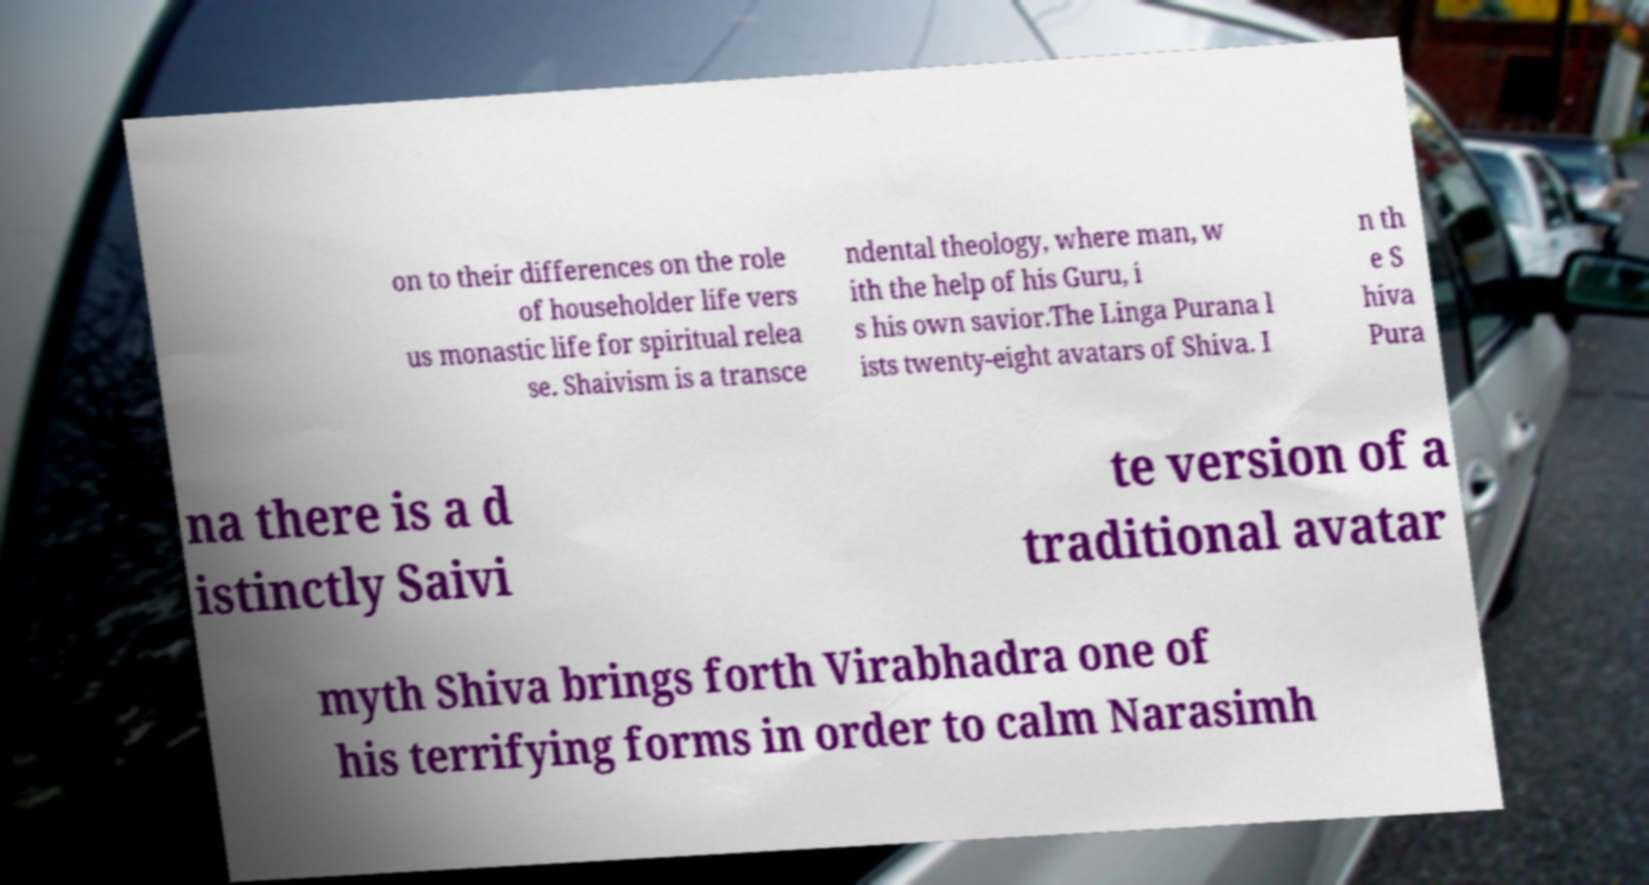Please identify and transcribe the text found in this image. on to their differences on the role of householder life vers us monastic life for spiritual relea se. Shaivism is a transce ndental theology, where man, w ith the help of his Guru, i s his own savior.The Linga Purana l ists twenty-eight avatars of Shiva. I n th e S hiva Pura na there is a d istinctly Saivi te version of a traditional avatar myth Shiva brings forth Virabhadra one of his terrifying forms in order to calm Narasimh 